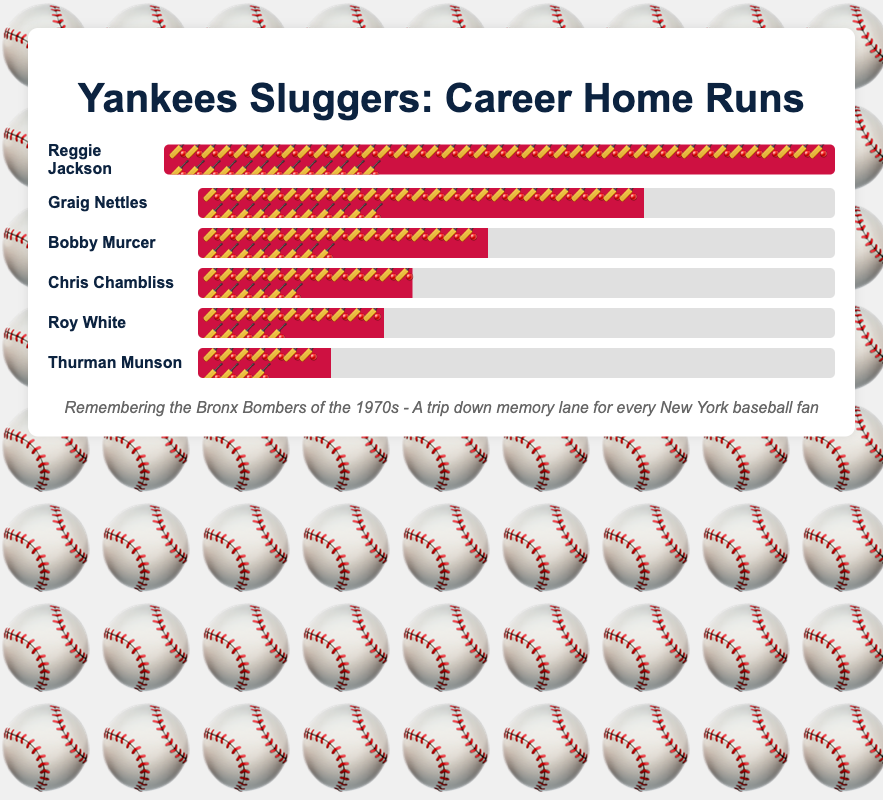Which player hit the most home runs? Reggie Jackson hit the most home runs among the listed players with a total of 563 home runs, as indicated by the length of the bat emoji bar and the number next to his name.
Answer: Reggie Jackson Which player has the shortest bar with the fewest bat emojis? Thurman Munson has the shortest bar with the fewest bat emojis (11 emojis), representing 113 home runs, which is the lowest count on the chart.
Answer: Thurman Munson How many more home runs did Graig Nettles hit than Roy White? Graig Nettles hit 390 home runs, while Roy White hit 160 home runs. The difference is calculated as 390 - 160 = 230 fewer home runs.
Answer: 230 What's the combined total of home runs for all the players? Adding up the home runs for all players: 563 (Reggie Jackson) + 390 (Graig Nettles) + 113 (Thurman Munson) + 160 (Roy White) + 252 (Bobby Murcer) + 185 (Chris Chambliss) equals 1663.
Answer: 1663 Who has more home runs, Bobby Murcer or Chris Chambliss? Bobby Murcer hit more home runs with a total of 252 compared to Chris Chambliss' 185 home runs, as shown by the longer bar and greater number of bat emojis for Murcer.
Answer: Bobby Murcer Arrange the players in descending order of home runs. The players arranged by home runs in descending order are: Reggie Jackson (563), Graig Nettles (390), Bobby Murcer (252), Chris Chambliss (185), Roy White (160), Thurman Munson (113).
Answer: Reggie Jackson, Graig Nettles, Bobby Murcer, Chris Chambliss, Roy White, Thurman Munson What percentage of Reggie Jackson's home runs did Roy White hit? Roy White hit 160 home runs, and Reggie Jackson hit 563 home runs. The percentage is calculated as (160 / 563) * 100 ≈ 28.42%.
Answer: 28.42% Which player is exactly in the middle of the chart in terms of home run totals? Bobby Murcer, with 252 home runs, is the third player listed in descending order from the top, making him the middle player in this chart.
Answer: Bobby Murcer 